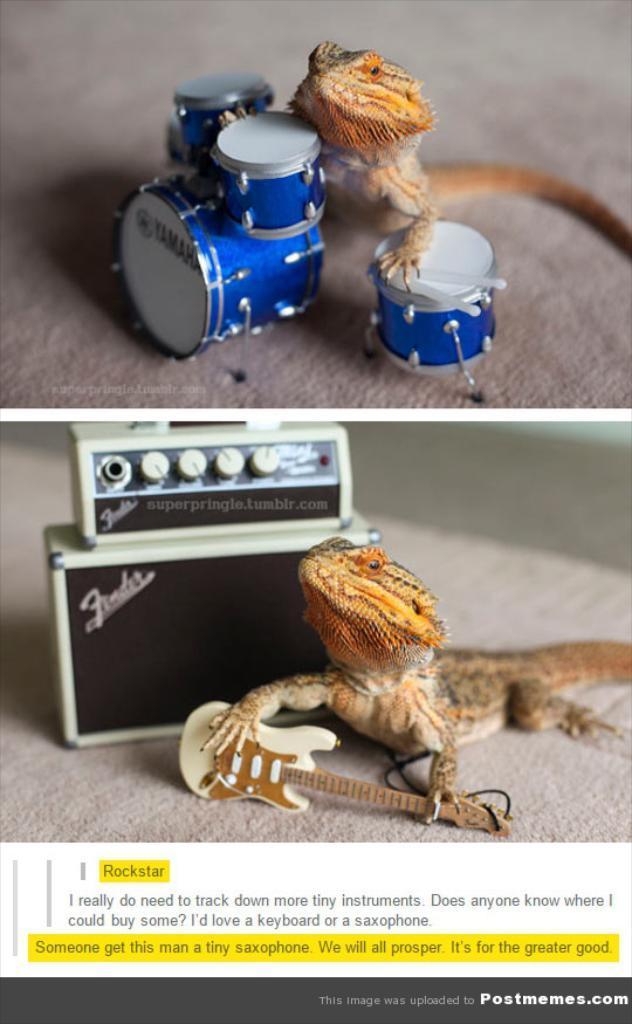How would you summarize this image in a sentence or two? In the picture we can see two images, in the first image we can see a lizard near the small musical drums, which are blue in color and in the second image we can see a lizard holding a guitar and behind it, we can see a music box with some buttons to it, and under it we can see some information. 